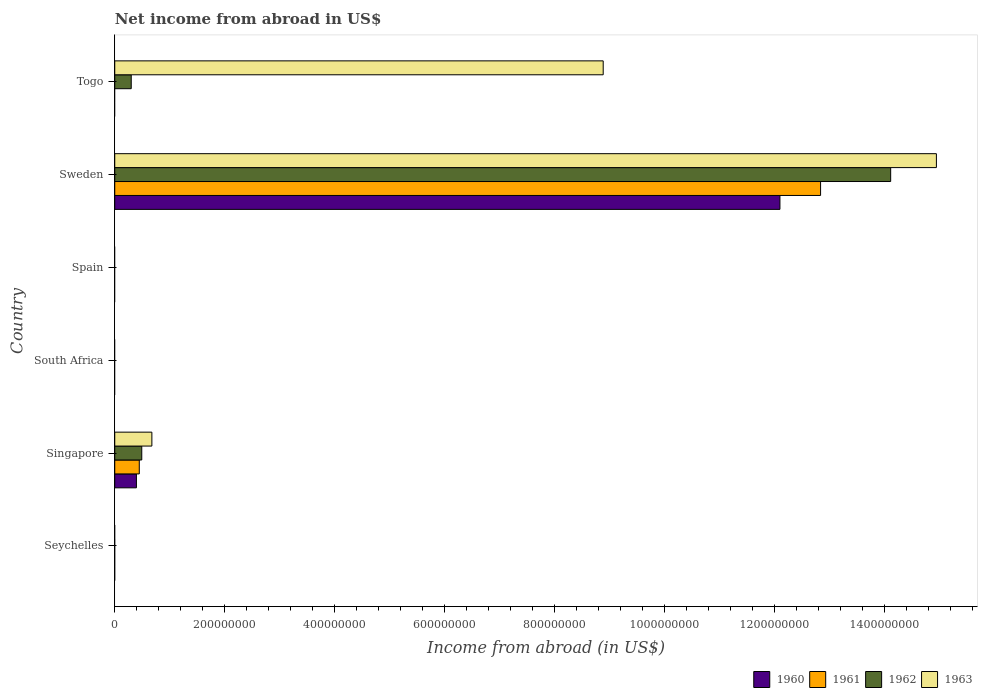How many different coloured bars are there?
Make the answer very short. 4. What is the label of the 5th group of bars from the top?
Your answer should be compact. Singapore. In how many cases, is the number of bars for a given country not equal to the number of legend labels?
Offer a terse response. 4. What is the net income from abroad in 1963 in Togo?
Offer a very short reply. 8.88e+08. Across all countries, what is the maximum net income from abroad in 1963?
Provide a short and direct response. 1.49e+09. What is the total net income from abroad in 1963 in the graph?
Offer a very short reply. 2.45e+09. What is the difference between the net income from abroad in 1963 in Sweden and that in Togo?
Your answer should be compact. 6.06e+08. What is the difference between the net income from abroad in 1960 in Singapore and the net income from abroad in 1961 in Spain?
Give a very brief answer. 3.94e+07. What is the average net income from abroad in 1961 per country?
Provide a short and direct response. 2.21e+08. What is the difference between the net income from abroad in 1960 and net income from abroad in 1961 in Sweden?
Provide a succinct answer. -7.39e+07. In how many countries, is the net income from abroad in 1963 greater than 800000000 US$?
Your response must be concise. 2. What is the difference between the highest and the second highest net income from abroad in 1963?
Offer a terse response. 6.06e+08. What is the difference between the highest and the lowest net income from abroad in 1962?
Offer a very short reply. 1.41e+09. In how many countries, is the net income from abroad in 1963 greater than the average net income from abroad in 1963 taken over all countries?
Your answer should be compact. 2. Is it the case that in every country, the sum of the net income from abroad in 1962 and net income from abroad in 1961 is greater than the sum of net income from abroad in 1960 and net income from abroad in 1963?
Your response must be concise. No. Is it the case that in every country, the sum of the net income from abroad in 1960 and net income from abroad in 1963 is greater than the net income from abroad in 1962?
Provide a short and direct response. No. Are all the bars in the graph horizontal?
Offer a terse response. Yes. What is the difference between two consecutive major ticks on the X-axis?
Keep it short and to the point. 2.00e+08. Are the values on the major ticks of X-axis written in scientific E-notation?
Give a very brief answer. No. Does the graph contain any zero values?
Your answer should be compact. Yes. Does the graph contain grids?
Provide a short and direct response. No. Where does the legend appear in the graph?
Keep it short and to the point. Bottom right. How many legend labels are there?
Provide a short and direct response. 4. What is the title of the graph?
Ensure brevity in your answer.  Net income from abroad in US$. What is the label or title of the X-axis?
Keep it short and to the point. Income from abroad (in US$). What is the Income from abroad (in US$) of 1960 in Seychelles?
Provide a succinct answer. 0. What is the Income from abroad (in US$) of 1962 in Seychelles?
Ensure brevity in your answer.  0. What is the Income from abroad (in US$) of 1960 in Singapore?
Keep it short and to the point. 3.94e+07. What is the Income from abroad (in US$) of 1961 in Singapore?
Your answer should be compact. 4.46e+07. What is the Income from abroad (in US$) of 1962 in Singapore?
Offer a terse response. 4.91e+07. What is the Income from abroad (in US$) in 1963 in Singapore?
Provide a short and direct response. 6.75e+07. What is the Income from abroad (in US$) in 1962 in South Africa?
Offer a terse response. 0. What is the Income from abroad (in US$) of 1963 in South Africa?
Provide a short and direct response. 0. What is the Income from abroad (in US$) of 1961 in Spain?
Ensure brevity in your answer.  0. What is the Income from abroad (in US$) of 1960 in Sweden?
Provide a succinct answer. 1.21e+09. What is the Income from abroad (in US$) of 1961 in Sweden?
Give a very brief answer. 1.28e+09. What is the Income from abroad (in US$) in 1962 in Sweden?
Provide a succinct answer. 1.41e+09. What is the Income from abroad (in US$) in 1963 in Sweden?
Make the answer very short. 1.49e+09. What is the Income from abroad (in US$) of 1960 in Togo?
Your answer should be very brief. 0. What is the Income from abroad (in US$) in 1961 in Togo?
Offer a terse response. 0. What is the Income from abroad (in US$) of 1962 in Togo?
Your answer should be compact. 3.00e+07. What is the Income from abroad (in US$) in 1963 in Togo?
Offer a very short reply. 8.88e+08. Across all countries, what is the maximum Income from abroad (in US$) of 1960?
Your answer should be very brief. 1.21e+09. Across all countries, what is the maximum Income from abroad (in US$) in 1961?
Your answer should be compact. 1.28e+09. Across all countries, what is the maximum Income from abroad (in US$) in 1962?
Keep it short and to the point. 1.41e+09. Across all countries, what is the maximum Income from abroad (in US$) in 1963?
Ensure brevity in your answer.  1.49e+09. Across all countries, what is the minimum Income from abroad (in US$) of 1960?
Make the answer very short. 0. Across all countries, what is the minimum Income from abroad (in US$) of 1961?
Ensure brevity in your answer.  0. Across all countries, what is the minimum Income from abroad (in US$) in 1962?
Provide a short and direct response. 0. What is the total Income from abroad (in US$) in 1960 in the graph?
Your response must be concise. 1.25e+09. What is the total Income from abroad (in US$) of 1961 in the graph?
Offer a very short reply. 1.33e+09. What is the total Income from abroad (in US$) in 1962 in the graph?
Offer a very short reply. 1.49e+09. What is the total Income from abroad (in US$) of 1963 in the graph?
Your answer should be compact. 2.45e+09. What is the difference between the Income from abroad (in US$) in 1960 in Singapore and that in Sweden?
Give a very brief answer. -1.17e+09. What is the difference between the Income from abroad (in US$) in 1961 in Singapore and that in Sweden?
Offer a very short reply. -1.24e+09. What is the difference between the Income from abroad (in US$) of 1962 in Singapore and that in Sweden?
Your answer should be compact. -1.36e+09. What is the difference between the Income from abroad (in US$) in 1963 in Singapore and that in Sweden?
Keep it short and to the point. -1.43e+09. What is the difference between the Income from abroad (in US$) in 1962 in Singapore and that in Togo?
Keep it short and to the point. 1.92e+07. What is the difference between the Income from abroad (in US$) of 1963 in Singapore and that in Togo?
Provide a succinct answer. -8.21e+08. What is the difference between the Income from abroad (in US$) of 1962 in Sweden and that in Togo?
Ensure brevity in your answer.  1.38e+09. What is the difference between the Income from abroad (in US$) in 1963 in Sweden and that in Togo?
Provide a short and direct response. 6.06e+08. What is the difference between the Income from abroad (in US$) of 1960 in Singapore and the Income from abroad (in US$) of 1961 in Sweden?
Your answer should be very brief. -1.24e+09. What is the difference between the Income from abroad (in US$) in 1960 in Singapore and the Income from abroad (in US$) in 1962 in Sweden?
Make the answer very short. -1.37e+09. What is the difference between the Income from abroad (in US$) in 1960 in Singapore and the Income from abroad (in US$) in 1963 in Sweden?
Keep it short and to the point. -1.45e+09. What is the difference between the Income from abroad (in US$) in 1961 in Singapore and the Income from abroad (in US$) in 1962 in Sweden?
Your answer should be very brief. -1.37e+09. What is the difference between the Income from abroad (in US$) in 1961 in Singapore and the Income from abroad (in US$) in 1963 in Sweden?
Give a very brief answer. -1.45e+09. What is the difference between the Income from abroad (in US$) of 1962 in Singapore and the Income from abroad (in US$) of 1963 in Sweden?
Your response must be concise. -1.44e+09. What is the difference between the Income from abroad (in US$) in 1960 in Singapore and the Income from abroad (in US$) in 1962 in Togo?
Your response must be concise. 9.45e+06. What is the difference between the Income from abroad (in US$) in 1960 in Singapore and the Income from abroad (in US$) in 1963 in Togo?
Provide a succinct answer. -8.49e+08. What is the difference between the Income from abroad (in US$) of 1961 in Singapore and the Income from abroad (in US$) of 1962 in Togo?
Provide a short and direct response. 1.46e+07. What is the difference between the Income from abroad (in US$) of 1961 in Singapore and the Income from abroad (in US$) of 1963 in Togo?
Your answer should be very brief. -8.44e+08. What is the difference between the Income from abroad (in US$) in 1962 in Singapore and the Income from abroad (in US$) in 1963 in Togo?
Provide a succinct answer. -8.39e+08. What is the difference between the Income from abroad (in US$) of 1960 in Sweden and the Income from abroad (in US$) of 1962 in Togo?
Provide a short and direct response. 1.18e+09. What is the difference between the Income from abroad (in US$) of 1960 in Sweden and the Income from abroad (in US$) of 1963 in Togo?
Provide a short and direct response. 3.21e+08. What is the difference between the Income from abroad (in US$) of 1961 in Sweden and the Income from abroad (in US$) of 1962 in Togo?
Your answer should be compact. 1.25e+09. What is the difference between the Income from abroad (in US$) of 1961 in Sweden and the Income from abroad (in US$) of 1963 in Togo?
Give a very brief answer. 3.95e+08. What is the difference between the Income from abroad (in US$) in 1962 in Sweden and the Income from abroad (in US$) in 1963 in Togo?
Ensure brevity in your answer.  5.23e+08. What is the average Income from abroad (in US$) of 1960 per country?
Provide a short and direct response. 2.08e+08. What is the average Income from abroad (in US$) in 1961 per country?
Your answer should be compact. 2.21e+08. What is the average Income from abroad (in US$) in 1962 per country?
Provide a short and direct response. 2.48e+08. What is the average Income from abroad (in US$) of 1963 per country?
Ensure brevity in your answer.  4.08e+08. What is the difference between the Income from abroad (in US$) in 1960 and Income from abroad (in US$) in 1961 in Singapore?
Offer a very short reply. -5.20e+06. What is the difference between the Income from abroad (in US$) in 1960 and Income from abroad (in US$) in 1962 in Singapore?
Keep it short and to the point. -9.70e+06. What is the difference between the Income from abroad (in US$) in 1960 and Income from abroad (in US$) in 1963 in Singapore?
Provide a short and direct response. -2.81e+07. What is the difference between the Income from abroad (in US$) of 1961 and Income from abroad (in US$) of 1962 in Singapore?
Provide a succinct answer. -4.50e+06. What is the difference between the Income from abroad (in US$) of 1961 and Income from abroad (in US$) of 1963 in Singapore?
Ensure brevity in your answer.  -2.29e+07. What is the difference between the Income from abroad (in US$) of 1962 and Income from abroad (in US$) of 1963 in Singapore?
Your answer should be compact. -1.84e+07. What is the difference between the Income from abroad (in US$) of 1960 and Income from abroad (in US$) of 1961 in Sweden?
Offer a very short reply. -7.39e+07. What is the difference between the Income from abroad (in US$) of 1960 and Income from abroad (in US$) of 1962 in Sweden?
Keep it short and to the point. -2.01e+08. What is the difference between the Income from abroad (in US$) of 1960 and Income from abroad (in US$) of 1963 in Sweden?
Provide a succinct answer. -2.84e+08. What is the difference between the Income from abroad (in US$) in 1961 and Income from abroad (in US$) in 1962 in Sweden?
Make the answer very short. -1.27e+08. What is the difference between the Income from abroad (in US$) in 1961 and Income from abroad (in US$) in 1963 in Sweden?
Your answer should be very brief. -2.11e+08. What is the difference between the Income from abroad (in US$) in 1962 and Income from abroad (in US$) in 1963 in Sweden?
Your answer should be very brief. -8.31e+07. What is the difference between the Income from abroad (in US$) of 1962 and Income from abroad (in US$) of 1963 in Togo?
Make the answer very short. -8.58e+08. What is the ratio of the Income from abroad (in US$) of 1960 in Singapore to that in Sweden?
Your response must be concise. 0.03. What is the ratio of the Income from abroad (in US$) in 1961 in Singapore to that in Sweden?
Ensure brevity in your answer.  0.03. What is the ratio of the Income from abroad (in US$) in 1962 in Singapore to that in Sweden?
Provide a succinct answer. 0.03. What is the ratio of the Income from abroad (in US$) in 1963 in Singapore to that in Sweden?
Provide a short and direct response. 0.05. What is the ratio of the Income from abroad (in US$) of 1962 in Singapore to that in Togo?
Your answer should be very brief. 1.64. What is the ratio of the Income from abroad (in US$) of 1963 in Singapore to that in Togo?
Keep it short and to the point. 0.08. What is the ratio of the Income from abroad (in US$) in 1962 in Sweden to that in Togo?
Keep it short and to the point. 47.1. What is the ratio of the Income from abroad (in US$) of 1963 in Sweden to that in Togo?
Your response must be concise. 1.68. What is the difference between the highest and the second highest Income from abroad (in US$) of 1962?
Ensure brevity in your answer.  1.36e+09. What is the difference between the highest and the second highest Income from abroad (in US$) in 1963?
Ensure brevity in your answer.  6.06e+08. What is the difference between the highest and the lowest Income from abroad (in US$) in 1960?
Make the answer very short. 1.21e+09. What is the difference between the highest and the lowest Income from abroad (in US$) of 1961?
Make the answer very short. 1.28e+09. What is the difference between the highest and the lowest Income from abroad (in US$) in 1962?
Your response must be concise. 1.41e+09. What is the difference between the highest and the lowest Income from abroad (in US$) of 1963?
Keep it short and to the point. 1.49e+09. 